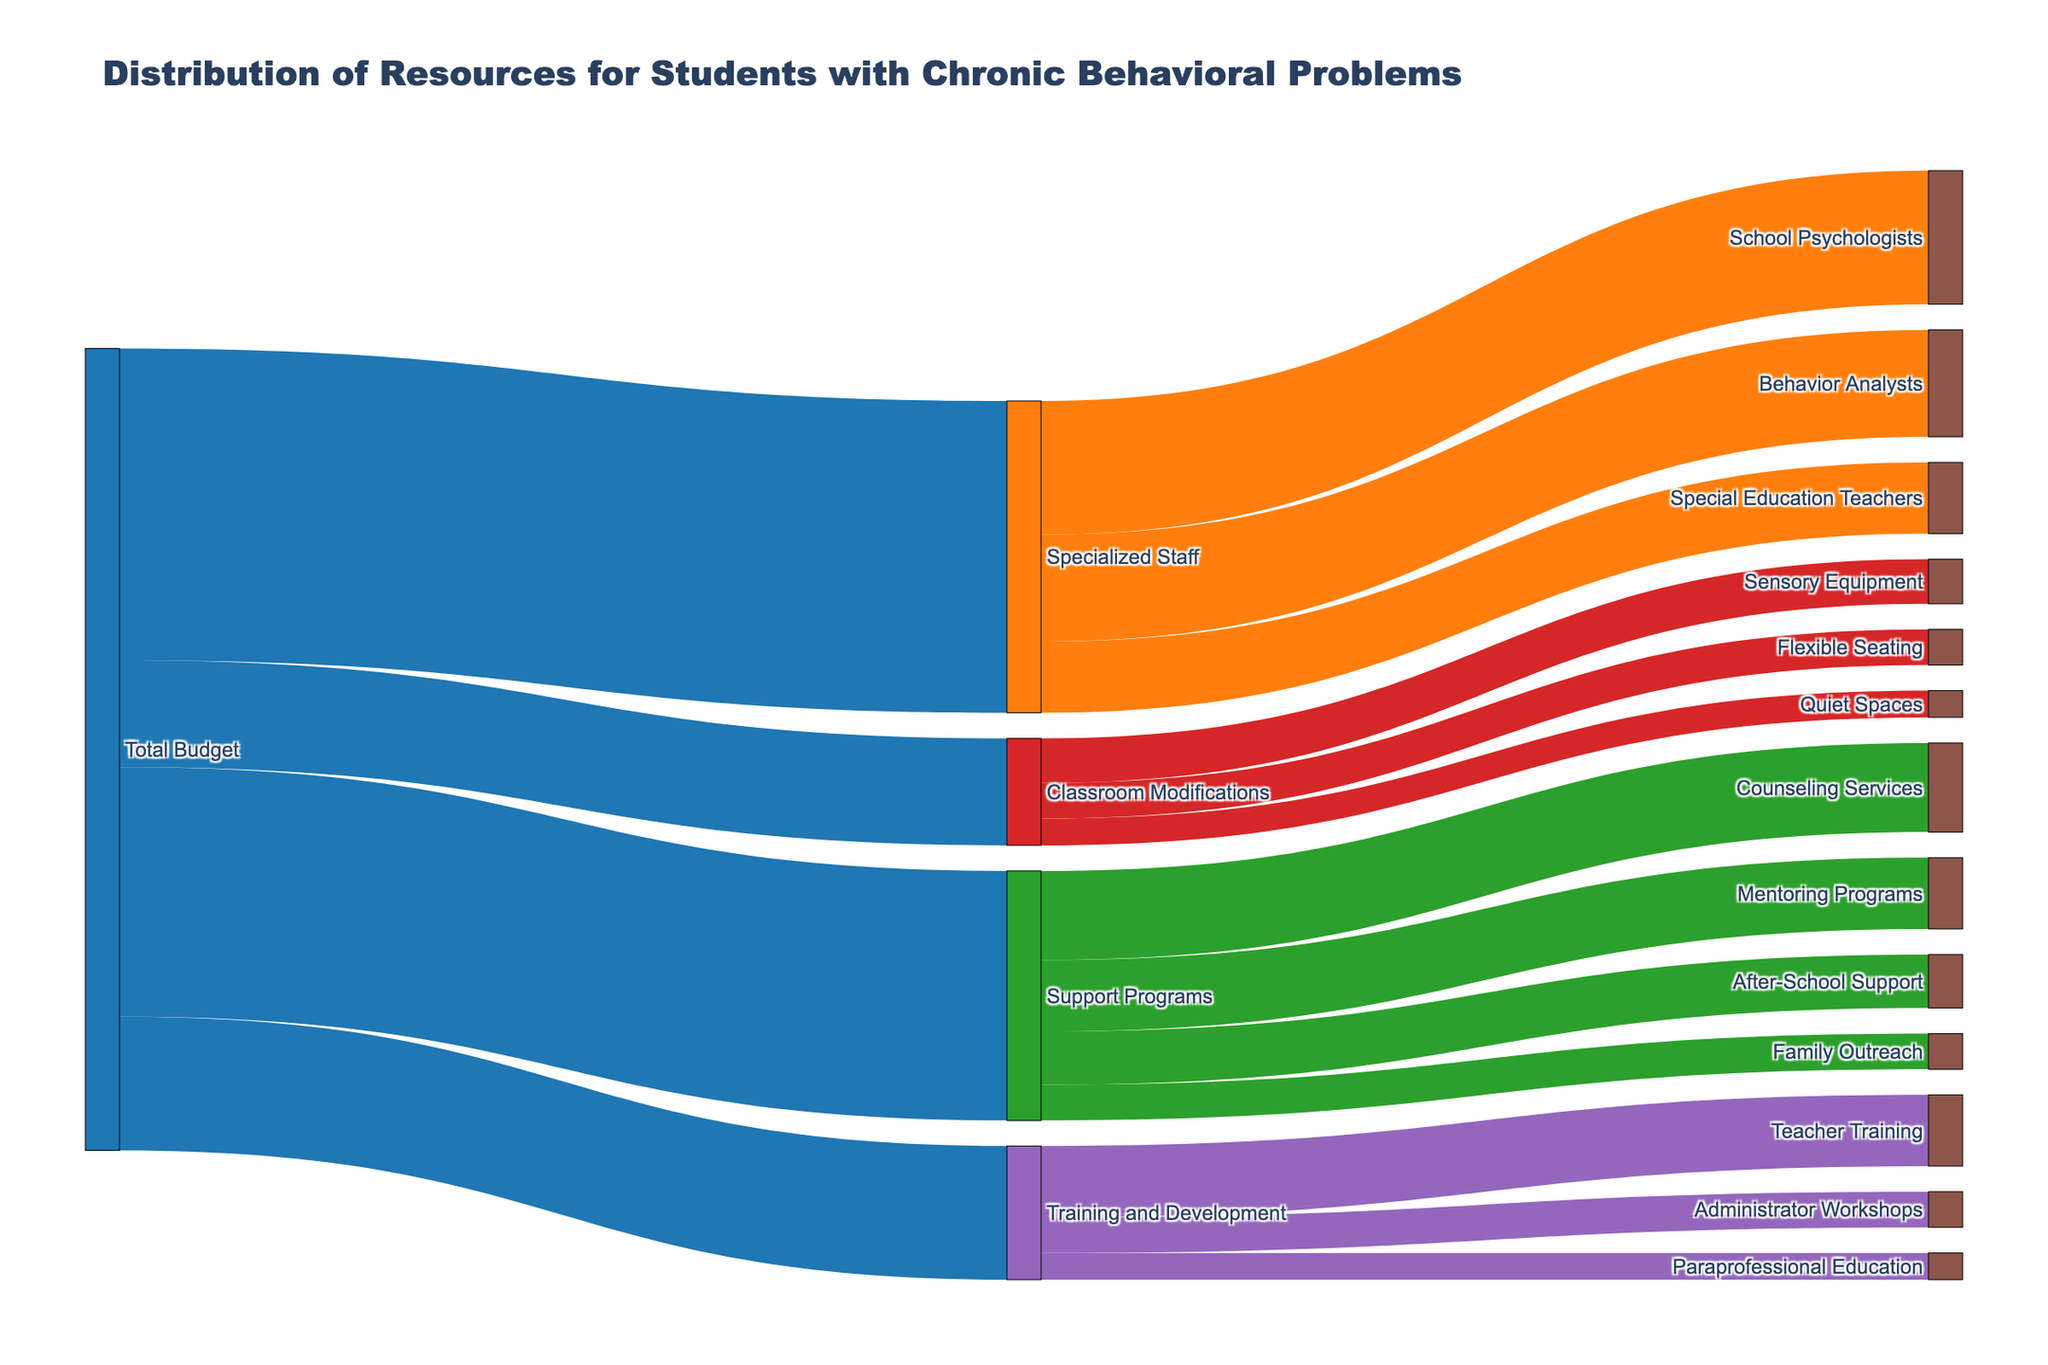What is the total budget allocated for distributing resources and support services? The total budget is represented by the flow from the "Total Budget" node to four different categories. Summing the values from "Total Budget": 3,500,000 (Specialized Staff) + 2,800,000 (Support Programs) + 1,200,000 (Classroom Modifications) + 1,500,000 (Training and Development) = 9,000,000
Answer: 9,000,000 Which area receives the largest portion of the budget from "Total Budget"? From the "Total Budget" node, the largest value flows to "Specialized Staff" which is 3,500,000
Answer: Specialized Staff How much budget is allocated to "Support Programs" and its sub-categories combined? The total for "Support Programs" and sub-categories is 2,800,000. Summing sub-categories: 1,000,000 (Counseling Services) + 800,000 (Mentoring Programs) + 600,000 (After-School Support) + 400,000 (Family Outreach) = 2,800,000
Answer: 2,800,000 Which area between "Training and Development" and "Classroom Modifications" gets more funding? The flow from "Total Budget" indicates "Training and Development" gets 1,500,000 while "Classroom Modifications" gets 1,200,000. So, "Training and Development" gets more funding.
Answer: Training and Development What specific service under "Classroom Modifications" has the smallest budget allocation? The sub-categories under "Classroom Modifications" and their values are: "Sensory Equipment" (500,000), "Flexible Seating" (400,000), and "Quiet Spaces" (300,000). The smallest allocation is "Quiet Spaces" at 300,000.
Answer: Quiet Spaces How is the budget for "Specialized Staff" distributed among its sub-categories? "School Psychologists" gets 1,500,000, "Behavior Analysts" gets 1,200,000, and "Special Education Teachers" gets 800,000.
Answer: School Psychologists: 1,500,000; Behavior Analysts: 1,200,000; Special Education Teachers: 800,000 Which has more funding: "Behavior Analysts" or "Counseling Services"? "Behavior Analysts" receives 1,200,000, and "Counseling Services" receives 1,000,000. Therefore, "Behavior Analysts" has more funding.
Answer: Behavior Analysts What percentage of the "Total Budget" is allocated to "Support Programs"? The allocation to "Support Programs" is 2,800,000. Percentage calculation: (2,800,000 / 9,000,000) * 100 = 31.11%
Answer: 31.11% Which sub-category under "Training and Development" has the highest budget? The sub-categories and their values are: "Teacher Training" (800,000), "Administrator Workshops" (400,000), and "Paraprofessional Education" (300,000). The highest budget is for "Teacher Training" at 800,000.
Answer: Teacher Training 